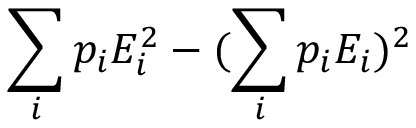<formula> <loc_0><loc_0><loc_500><loc_500>\sum _ { i } p _ { i } E _ { i } ^ { 2 } - ( \sum _ { i } p _ { i } E _ { i } ) ^ { 2 }</formula> 